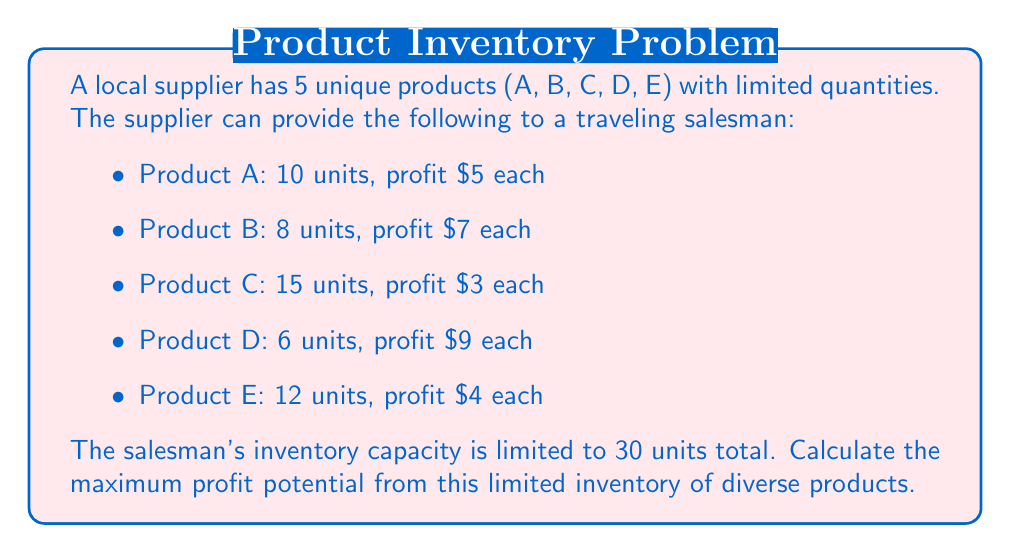Can you solve this math problem? To solve this problem, we can use the concept of linear programming from field theory. Let's approach this step-by-step:

1) Define variables:
   Let $x_A, x_B, x_C, x_D, x_E$ be the number of units of each product.

2) Objective function:
   Maximize profit: $P = 5x_A + 7x_B + 3x_C + 9x_D + 4x_E$

3) Constraints:
   $x_A \leq 10$
   $x_B \leq 8$
   $x_C \leq 15$
   $x_D \leq 6$
   $x_E \leq 12$
   $x_A + x_B + x_C + x_D + x_E \leq 30$
   $x_A, x_B, x_C, x_D, x_E \geq 0$ and integers

4) Solving strategy:
   Since we're dealing with integers, we'll use a greedy approach. We'll prioritize products with higher profit per unit until we reach the capacity limit.

5) Sorting products by profit:
   D ($9), B ($7), A ($5), E ($4), C ($3)

6) Allocating inventory:
   - Product D: Take all 6 units (6 * $9 = $54)
   - Product B: Take all 8 units (8 * $7 = $56)
   - Product A: Take all 10 units (10 * $5 = $50)
   - Product E: Take remaining 6 units (6 * $4 = $24)
   - Product C: No space left

7) Calculate total profit:
   $54 + $56 + $50 + $24 = $184

Therefore, the maximum profit potential is $184.
Answer: $184 